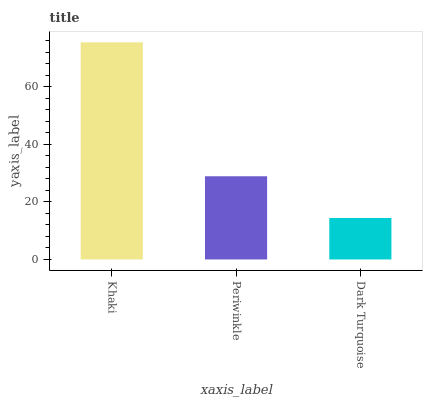Is Dark Turquoise the minimum?
Answer yes or no. Yes. Is Khaki the maximum?
Answer yes or no. Yes. Is Periwinkle the minimum?
Answer yes or no. No. Is Periwinkle the maximum?
Answer yes or no. No. Is Khaki greater than Periwinkle?
Answer yes or no. Yes. Is Periwinkle less than Khaki?
Answer yes or no. Yes. Is Periwinkle greater than Khaki?
Answer yes or no. No. Is Khaki less than Periwinkle?
Answer yes or no. No. Is Periwinkle the high median?
Answer yes or no. Yes. Is Periwinkle the low median?
Answer yes or no. Yes. Is Dark Turquoise the high median?
Answer yes or no. No. Is Dark Turquoise the low median?
Answer yes or no. No. 